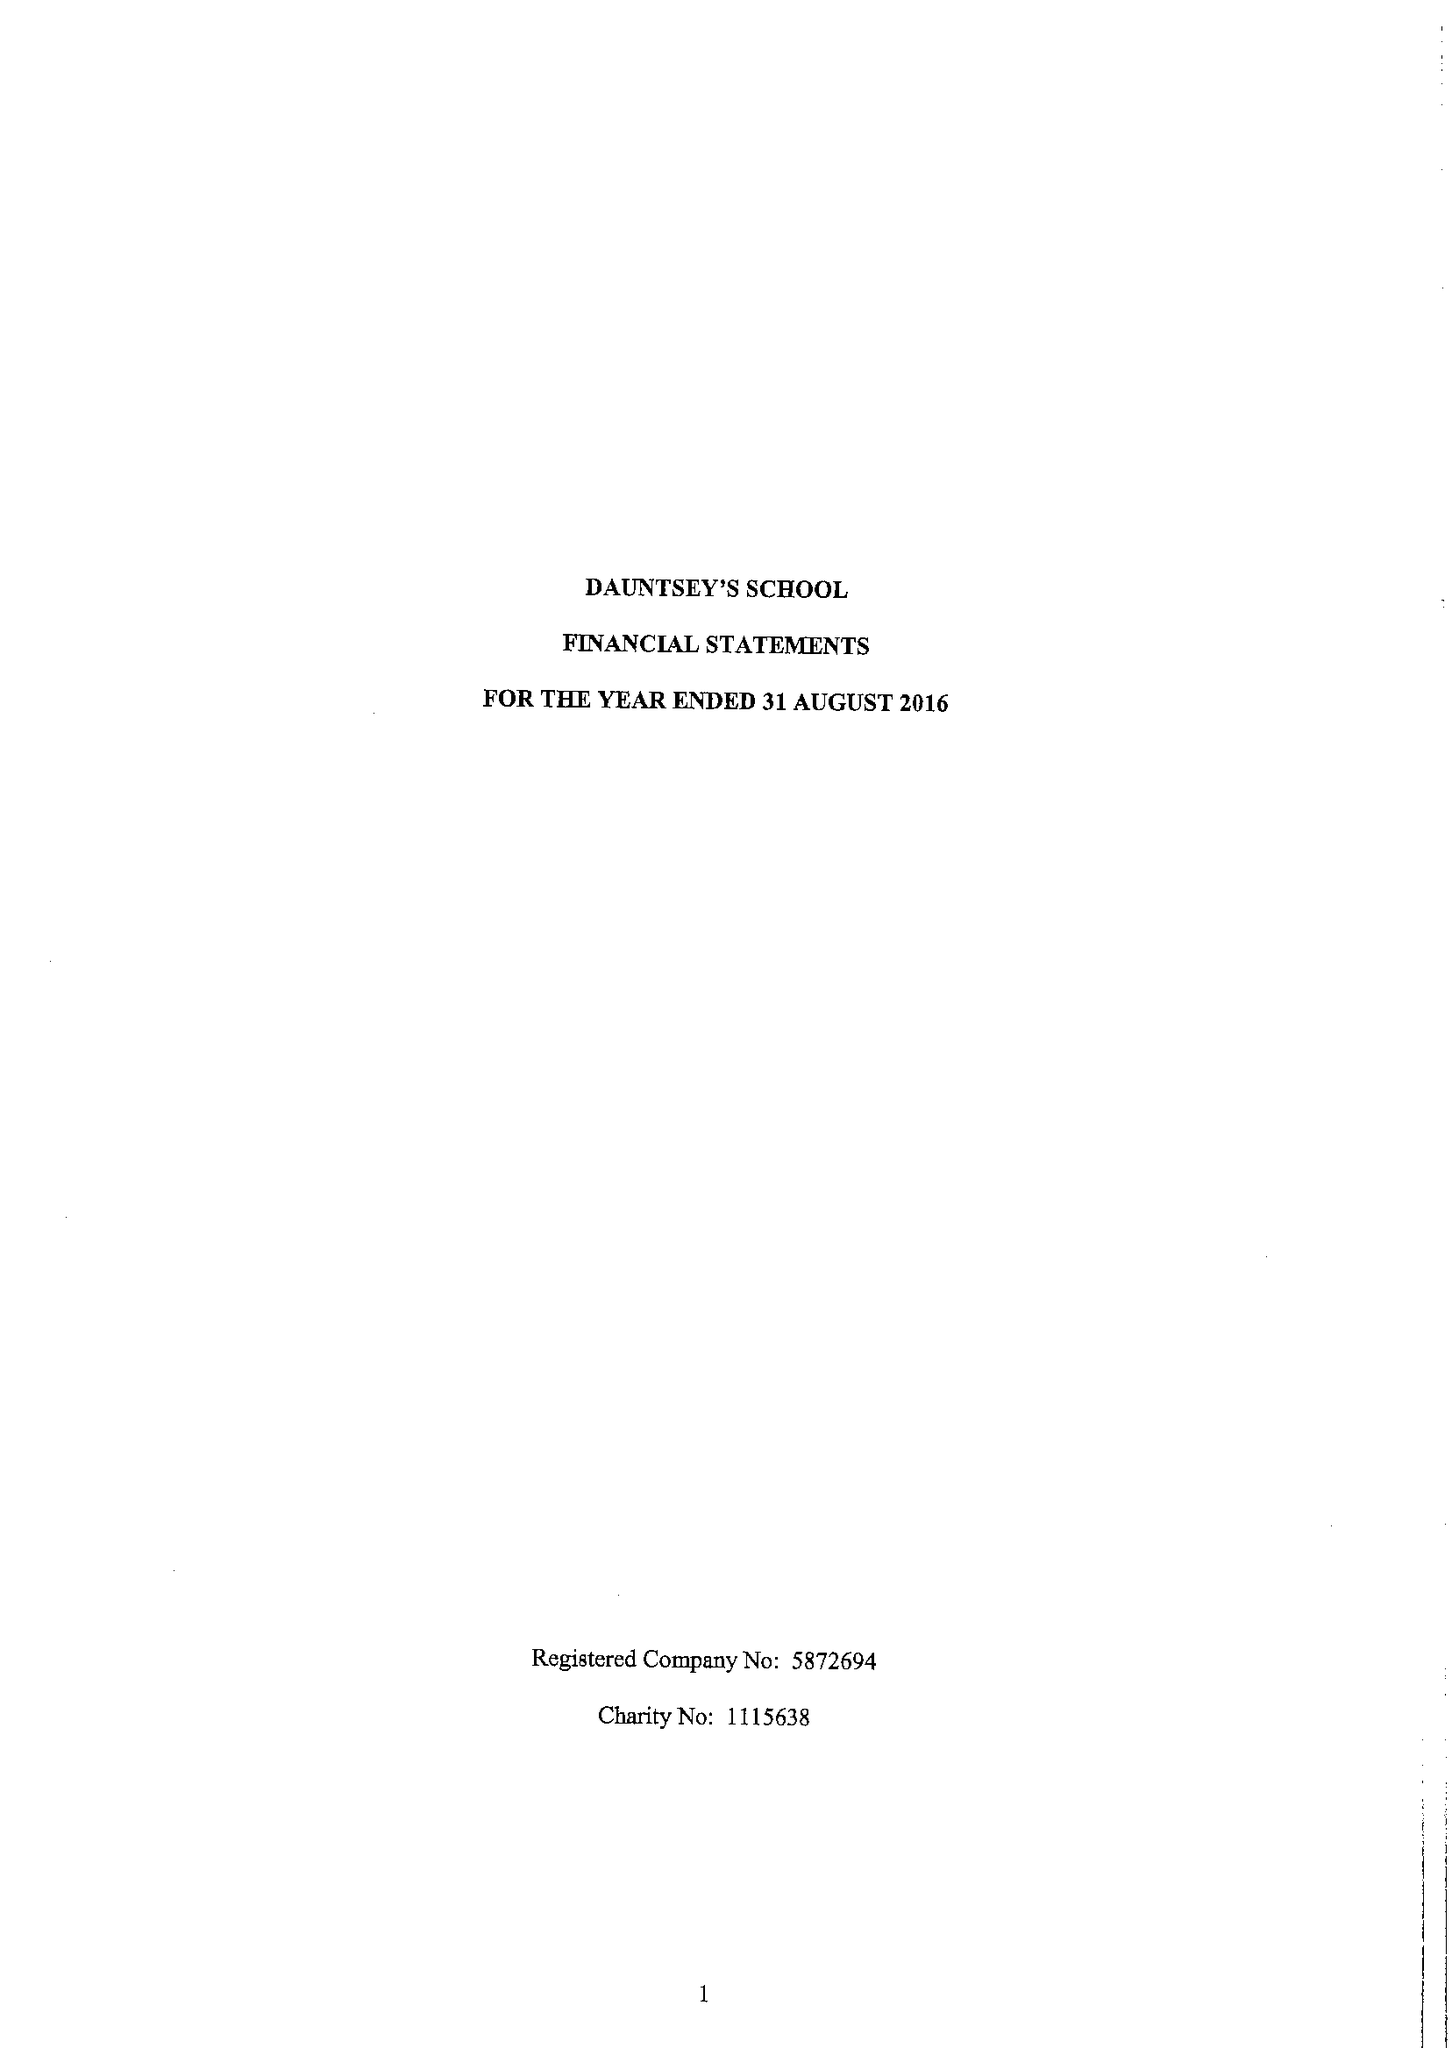What is the value for the report_date?
Answer the question using a single word or phrase. 2016-08-31 